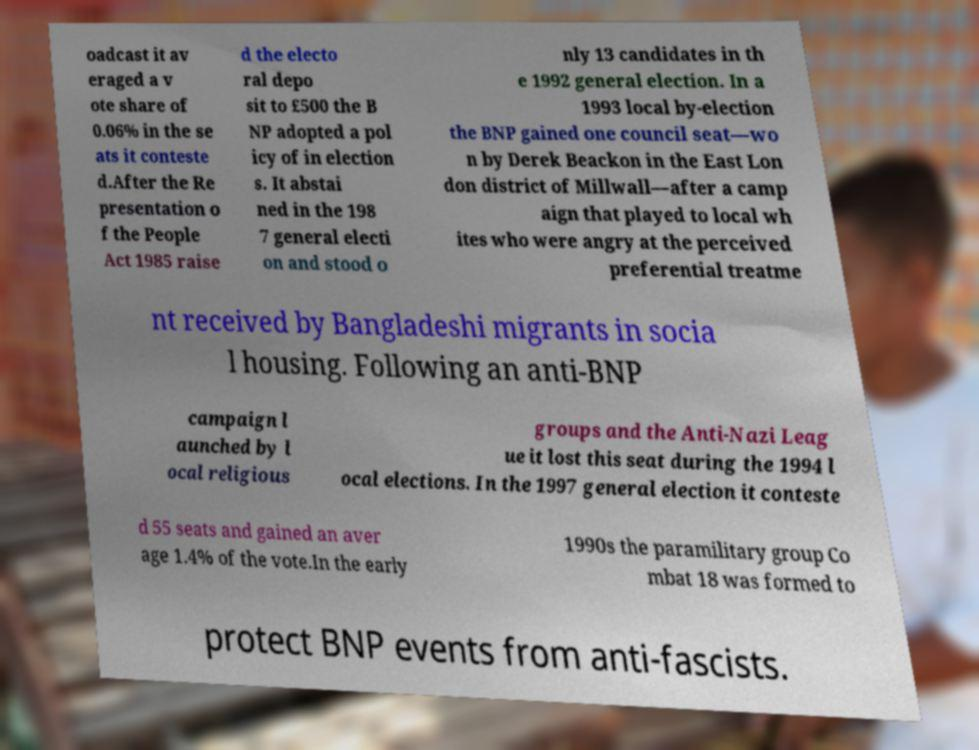Could you extract and type out the text from this image? oadcast it av eraged a v ote share of 0.06% in the se ats it conteste d.After the Re presentation o f the People Act 1985 raise d the electo ral depo sit to £500 the B NP adopted a pol icy of in election s. It abstai ned in the 198 7 general electi on and stood o nly 13 candidates in th e 1992 general election. In a 1993 local by-election the BNP gained one council seat—wo n by Derek Beackon in the East Lon don district of Millwall—after a camp aign that played to local wh ites who were angry at the perceived preferential treatme nt received by Bangladeshi migrants in socia l housing. Following an anti-BNP campaign l aunched by l ocal religious groups and the Anti-Nazi Leag ue it lost this seat during the 1994 l ocal elections. In the 1997 general election it conteste d 55 seats and gained an aver age 1.4% of the vote.In the early 1990s the paramilitary group Co mbat 18 was formed to protect BNP events from anti-fascists. 